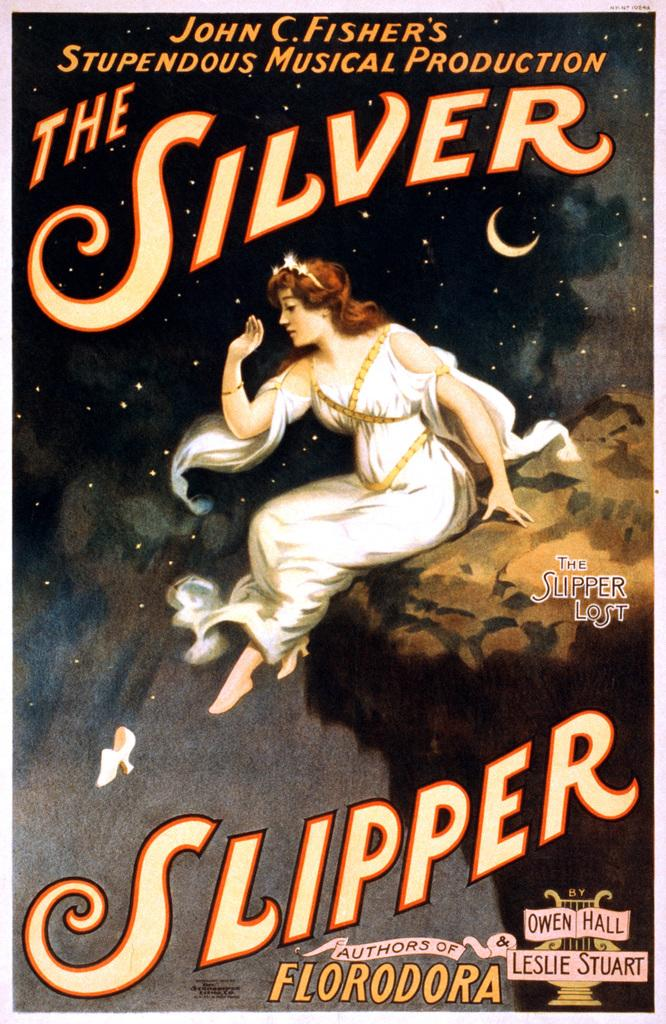<image>
Provide a brief description of the given image. The Silver Slipper is a musical production from John C. Fisher. 